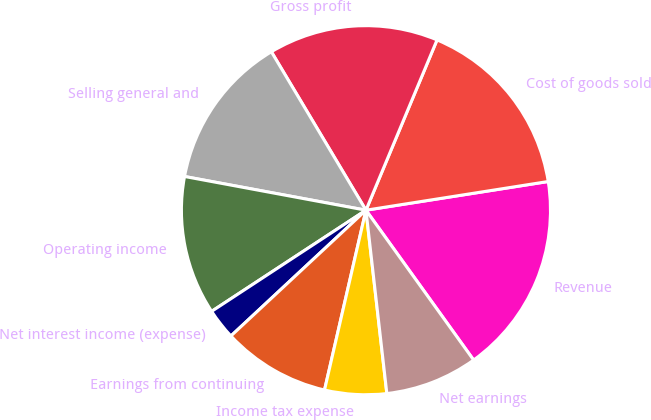<chart> <loc_0><loc_0><loc_500><loc_500><pie_chart><fcel>Revenue<fcel>Cost of goods sold<fcel>Gross profit<fcel>Selling general and<fcel>Operating income<fcel>Net interest income (expense)<fcel>Earnings from continuing<fcel>Income tax expense<fcel>Net earnings<nl><fcel>17.57%<fcel>16.22%<fcel>14.86%<fcel>13.51%<fcel>12.16%<fcel>2.7%<fcel>9.46%<fcel>5.41%<fcel>8.11%<nl></chart> 